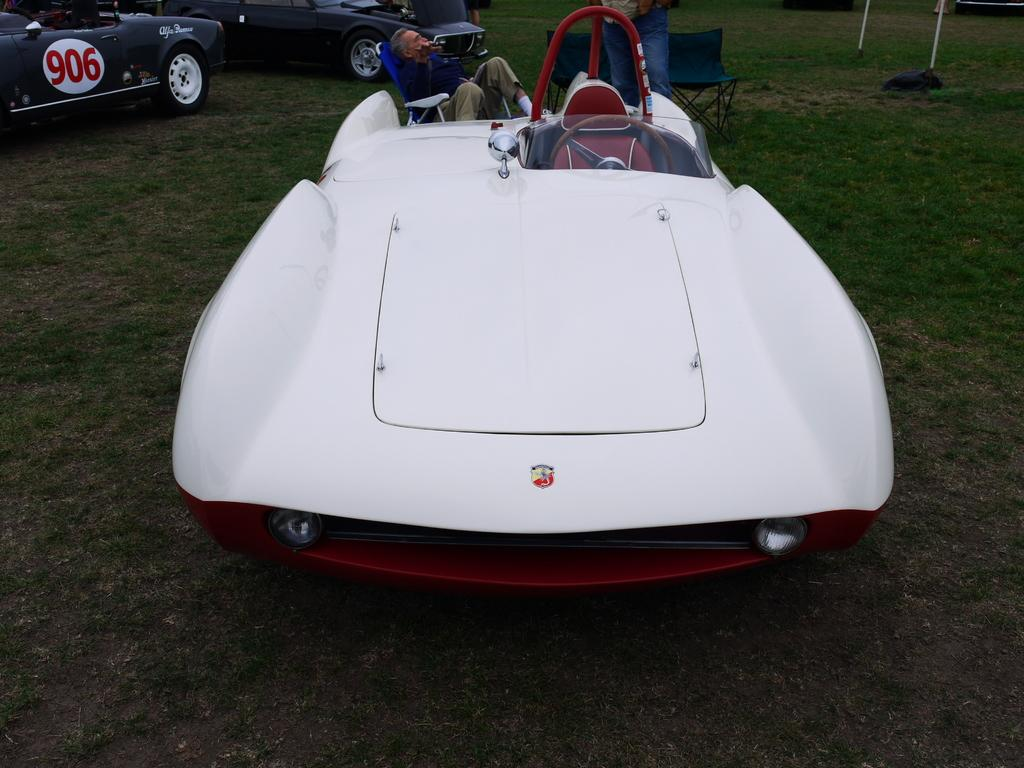What type of vehicles are on the grass in the image? There are three vehicles on the grass in the image. Can you describe the people visible in the image? Two people are visible at the top of the image, and one person is sitting on a chair. How many chairs are present in the image? There are chairs present in the image. What else can be seen in the image besides the vehicles, people, and chairs? There are poles visible in the image. What note is the father playing on the train in the image? There is no father, note, or train present in the image. 